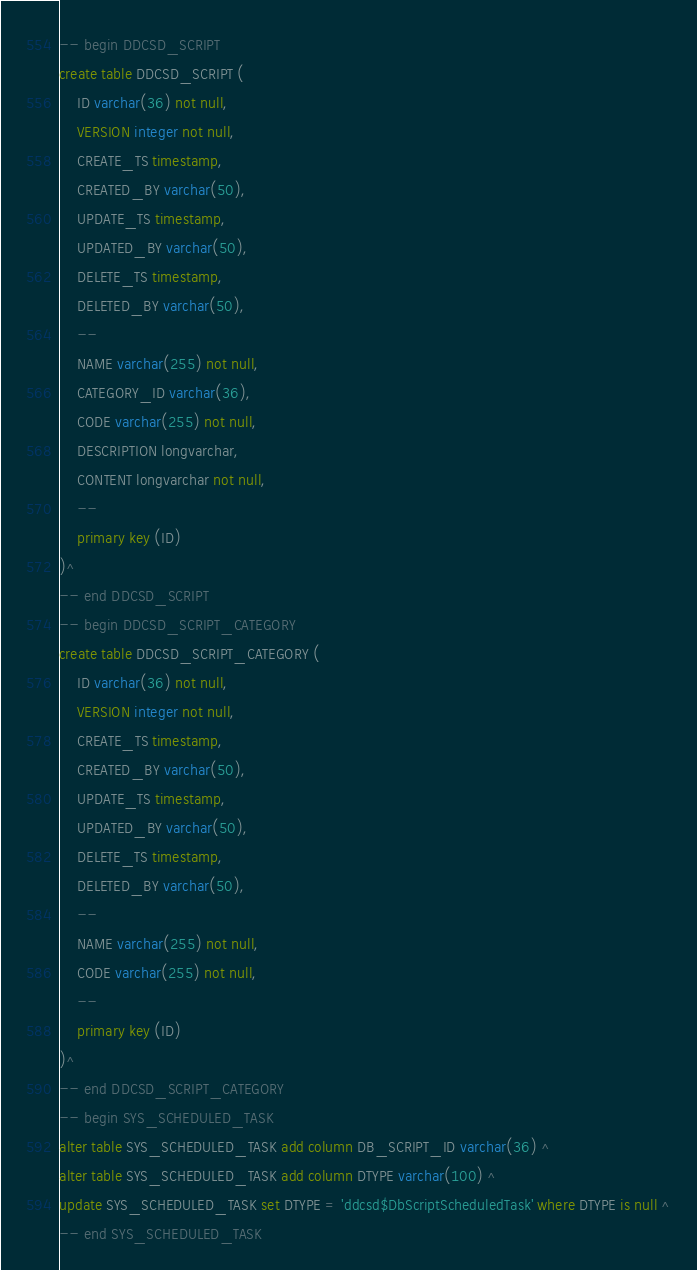<code> <loc_0><loc_0><loc_500><loc_500><_SQL_>-- begin DDCSD_SCRIPT
create table DDCSD_SCRIPT (
    ID varchar(36) not null,
    VERSION integer not null,
    CREATE_TS timestamp,
    CREATED_BY varchar(50),
    UPDATE_TS timestamp,
    UPDATED_BY varchar(50),
    DELETE_TS timestamp,
    DELETED_BY varchar(50),
    --
    NAME varchar(255) not null,
    CATEGORY_ID varchar(36),
    CODE varchar(255) not null,
    DESCRIPTION longvarchar,
    CONTENT longvarchar not null,
    --
    primary key (ID)
)^
-- end DDCSD_SCRIPT
-- begin DDCSD_SCRIPT_CATEGORY
create table DDCSD_SCRIPT_CATEGORY (
    ID varchar(36) not null,
    VERSION integer not null,
    CREATE_TS timestamp,
    CREATED_BY varchar(50),
    UPDATE_TS timestamp,
    UPDATED_BY varchar(50),
    DELETE_TS timestamp,
    DELETED_BY varchar(50),
    --
    NAME varchar(255) not null,
    CODE varchar(255) not null,
    --
    primary key (ID)
)^
-- end DDCSD_SCRIPT_CATEGORY
-- begin SYS_SCHEDULED_TASK
alter table SYS_SCHEDULED_TASK add column DB_SCRIPT_ID varchar(36) ^
alter table SYS_SCHEDULED_TASK add column DTYPE varchar(100) ^
update SYS_SCHEDULED_TASK set DTYPE = 'ddcsd$DbScriptScheduledTask' where DTYPE is null ^
-- end SYS_SCHEDULED_TASK
</code> 